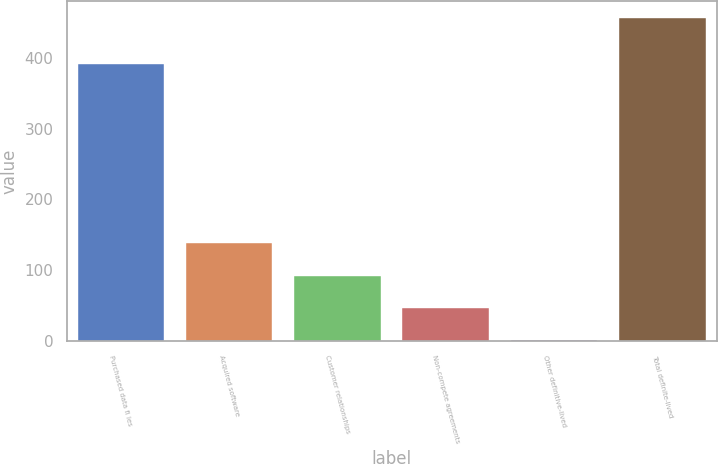<chart> <loc_0><loc_0><loc_500><loc_500><bar_chart><fcel>Purchased data fi les<fcel>Acquired software<fcel>Customer relationships<fcel>Non-compete agreements<fcel>Other definitive-lived<fcel>Total definite-lived<nl><fcel>390.8<fcel>138.29<fcel>92.86<fcel>47.43<fcel>2<fcel>456.3<nl></chart> 